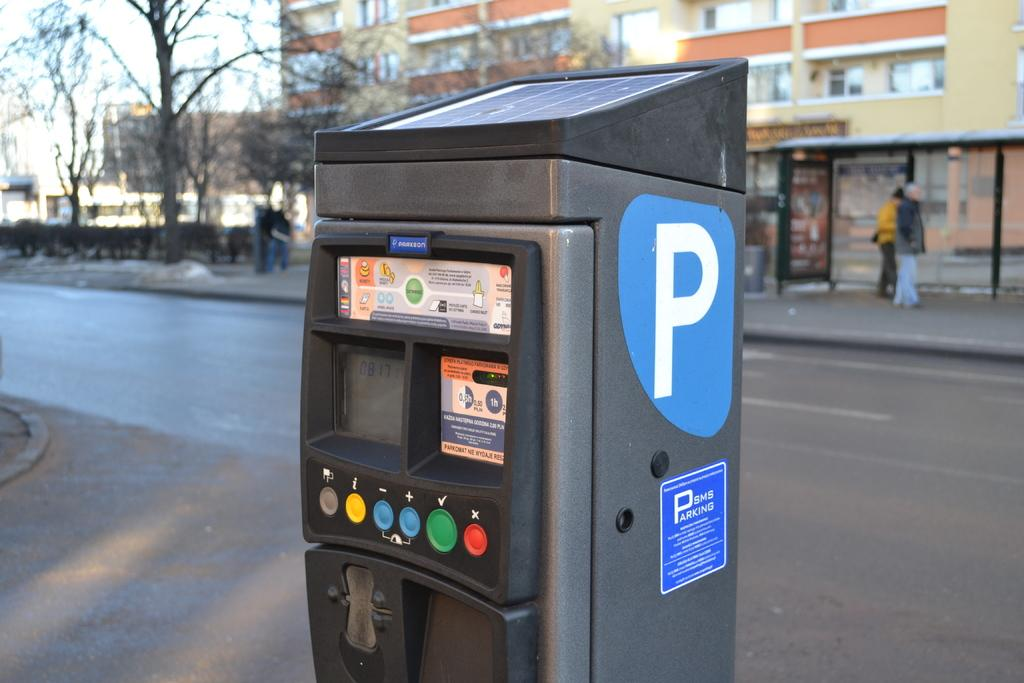<image>
Share a concise interpretation of the image provided. Parking meter with a giant sticker that has the letter P on it. 